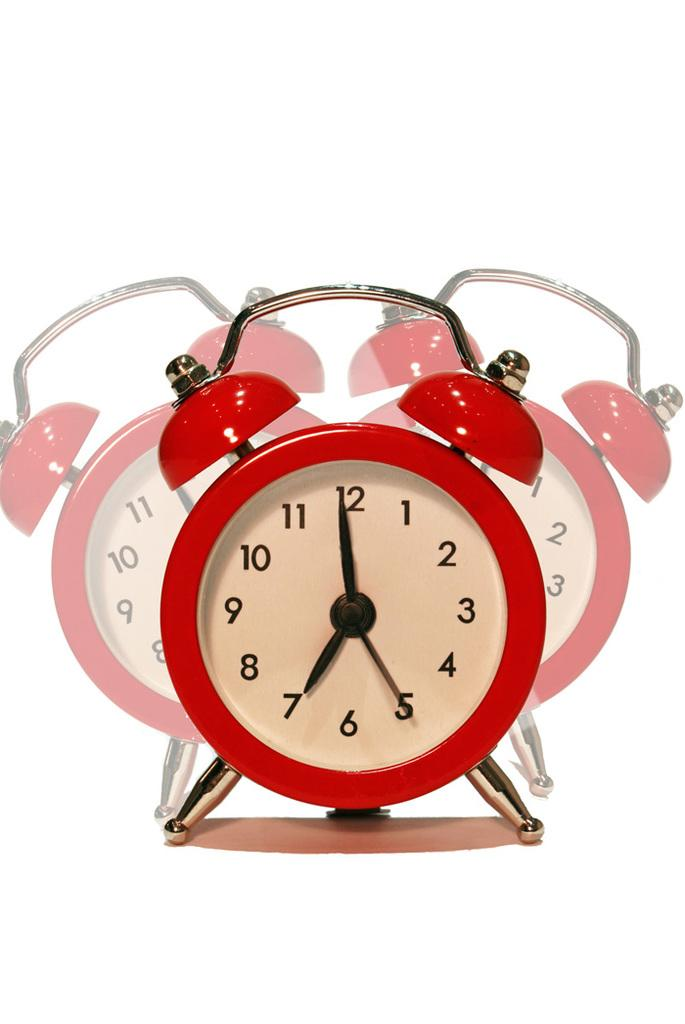<image>
Create a compact narrative representing the image presented. A red clock with the hour hand pointing to the number 7 